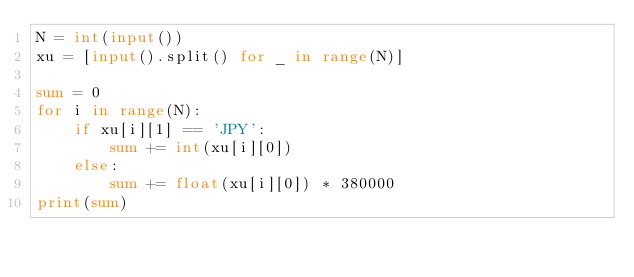Convert code to text. <code><loc_0><loc_0><loc_500><loc_500><_Python_>N = int(input())
xu = [input().split() for _ in range(N)]

sum = 0
for i in range(N):
    if xu[i][1] == 'JPY':
        sum += int(xu[i][0])
    else:
        sum += float(xu[i][0]) * 380000
print(sum)
</code> 